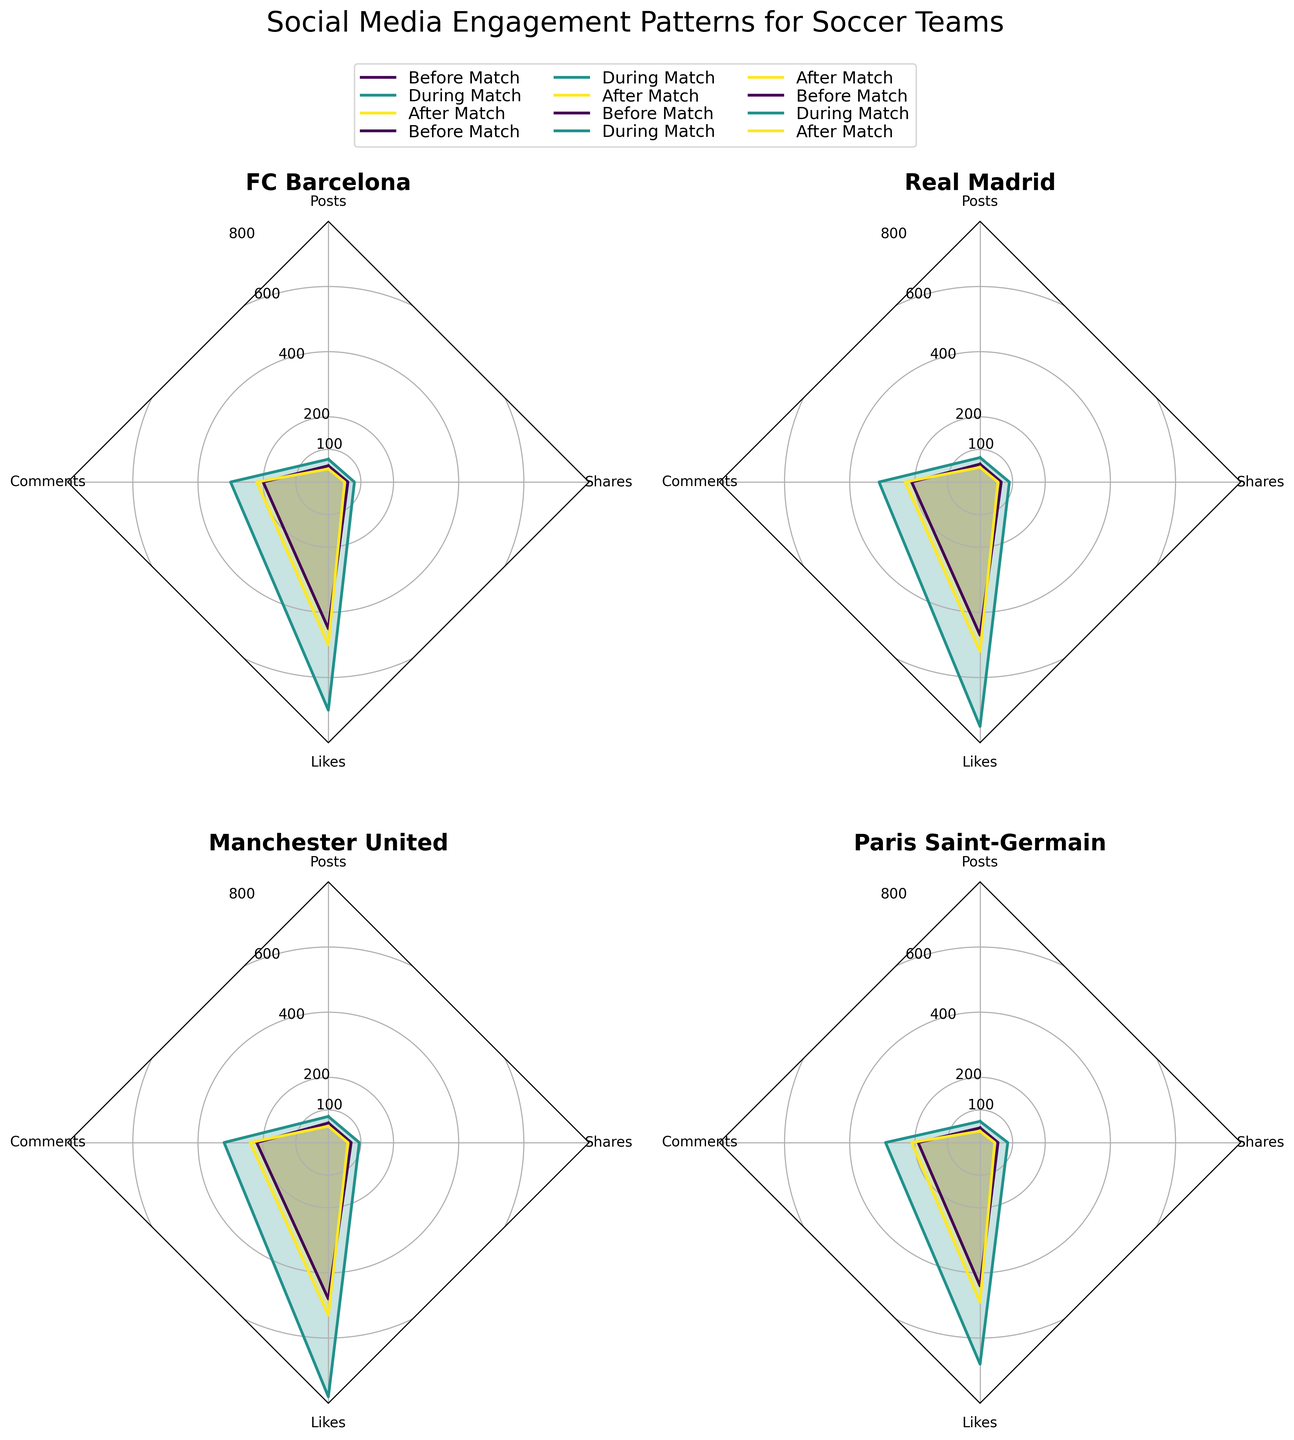What is the title of the figure? The title is located at the top of the figure in larger font size and is descriptive of the content of the chart.
Answer: Social Media Engagement Patterns for Soccer Teams Which team has the highest number of "Likes" during the match? Look at the "Likes" values for each team specifically during the match and identify the highest one. Compare the peak value across FC Barcelona, Real Madrid, Manchester United, and Paris Saint-Germain.
Answer: Manchester United (780) How does the number of "Posts" for FC Barcelona compare before, during, and after the match? Check the values indicated for "Posts" for FC Barcelona at the three different times (Before Match, During Match, After Match) and note the differences.
Answer: 50 (Before), 70 (During), 40 (After) What trend can you observe for "Comments" by Real Madrid across the different match times? Analyze the "Comments" values for Real Madrid before, during, and after the match to see if they increase, decrease, or show any specific pattern.
Answer: Increase from 210 (Before) to 310 (During), then slightly to 230 (After) Which metric shows the maximum value across all teams and times? Identify and compare all the value peaks in the different metrics (Posts, Comments, Likes, Shares) for any team at any time point.
Answer: Likes (Manchester United, During Match, 780) Which time period shows the highest engagement in terms of "Shares" for any team? Check all "Shares" values for all teams at all three times and identify the maximum value.
Answer: Manchester United (During Match, 95) What is the average number of "Likes" during the match for all teams? Calculate the average by summing the "Likes" values during the match for all teams and dividing by the number of teams.
Answer: (700 + 750 + 780 + 680) / 4 = 727.5 How do the "Posts" counts for Paris Saint-Germain and FC Barcelona after the match compare? Directly compare the "Posts" counts for these two teams after the match.
Answer: Paris Saint-Germain (35) has fewer posts than FC Barcelona (40) Which metric for Manchester United sees the highest increase from before to during the match? Evaluate the differences between the values before and during the match for each metric (Posts, Comments, Likes, Shares) for Manchester United.
Answer: Likes (increases by 300) 